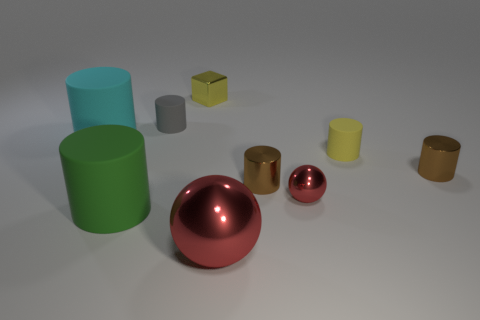Subtract all brown cylinders. How many cylinders are left? 4 Subtract all large cyan matte cylinders. How many cylinders are left? 5 Subtract all cyan balls. Subtract all yellow cylinders. How many balls are left? 2 Subtract all cylinders. How many objects are left? 3 Add 7 green rubber things. How many green rubber things are left? 8 Add 9 tiny red objects. How many tiny red objects exist? 10 Subtract 2 red balls. How many objects are left? 7 Subtract all tiny yellow shiny things. Subtract all gray objects. How many objects are left? 7 